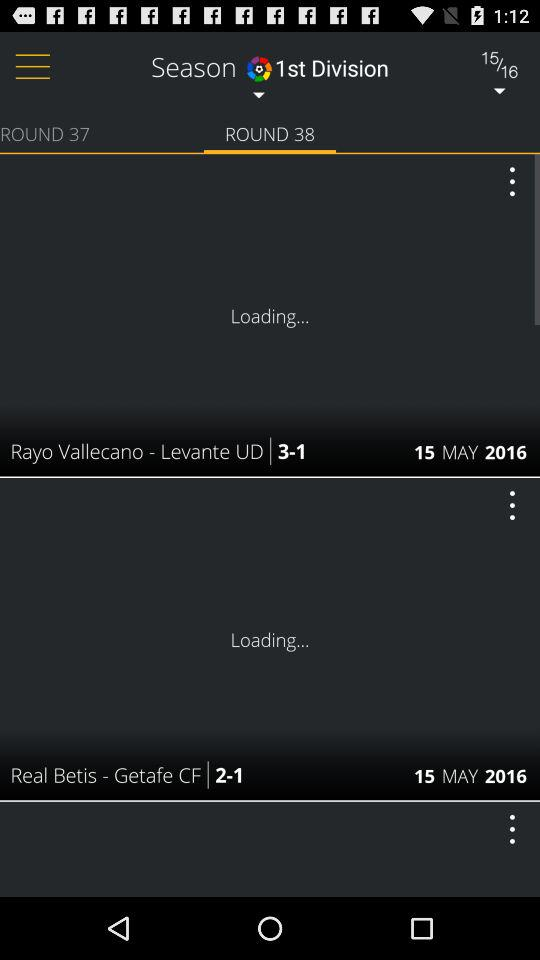How many matches are displayed in the screen?
Answer the question using a single word or phrase. 2 